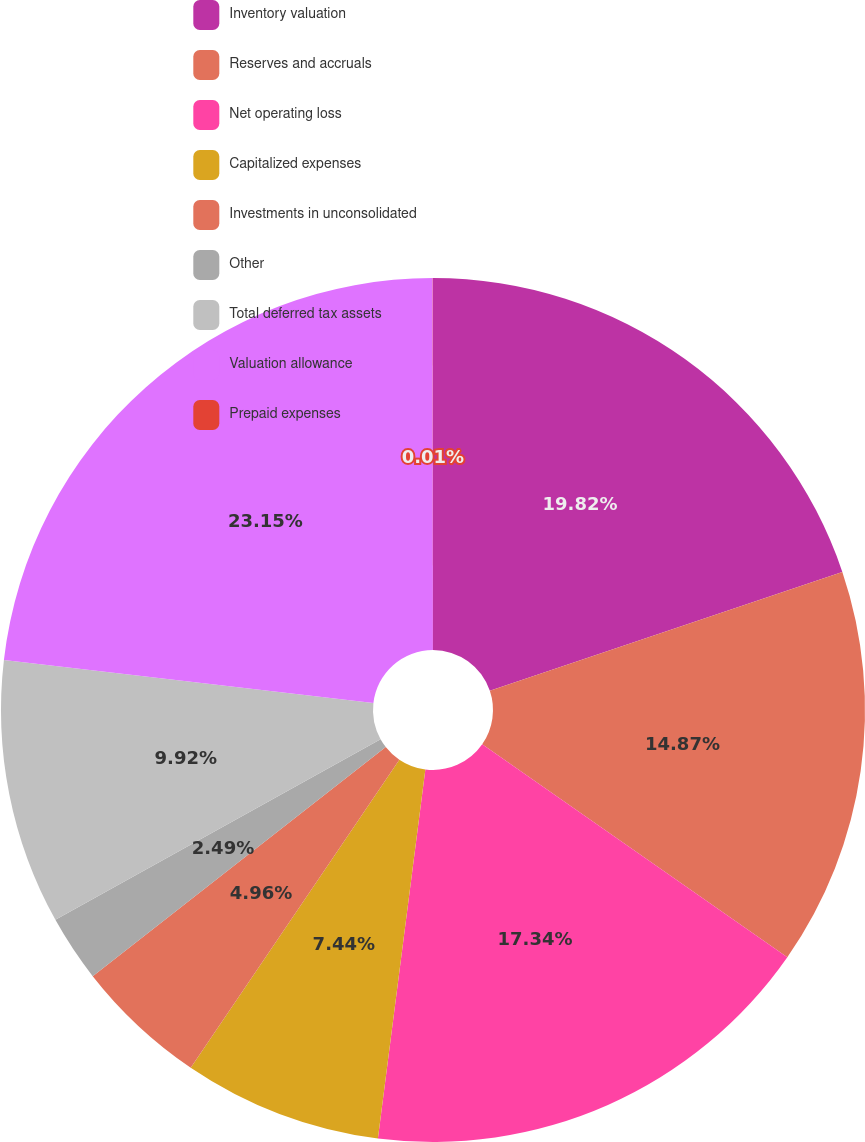<chart> <loc_0><loc_0><loc_500><loc_500><pie_chart><fcel>Inventory valuation<fcel>Reserves and accruals<fcel>Net operating loss<fcel>Capitalized expenses<fcel>Investments in unconsolidated<fcel>Other<fcel>Total deferred tax assets<fcel>Valuation allowance<fcel>Prepaid expenses<nl><fcel>19.82%<fcel>14.87%<fcel>17.34%<fcel>7.44%<fcel>4.96%<fcel>2.49%<fcel>9.92%<fcel>23.14%<fcel>0.01%<nl></chart> 